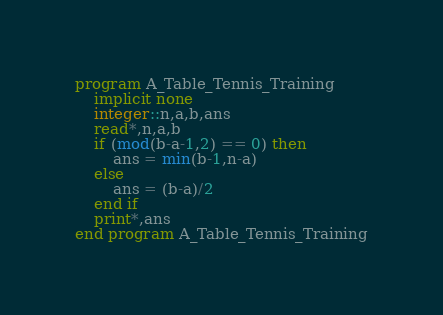<code> <loc_0><loc_0><loc_500><loc_500><_FORTRAN_>program A_Table_Tennis_Training
    implicit none
    integer::n,a,b,ans
    read*,n,a,b
    if (mod(b-a-1,2) == 0) then
        ans = min(b-1,n-a)
    else
        ans = (b-a)/2
    end if 
    print*,ans
end program A_Table_Tennis_Training</code> 